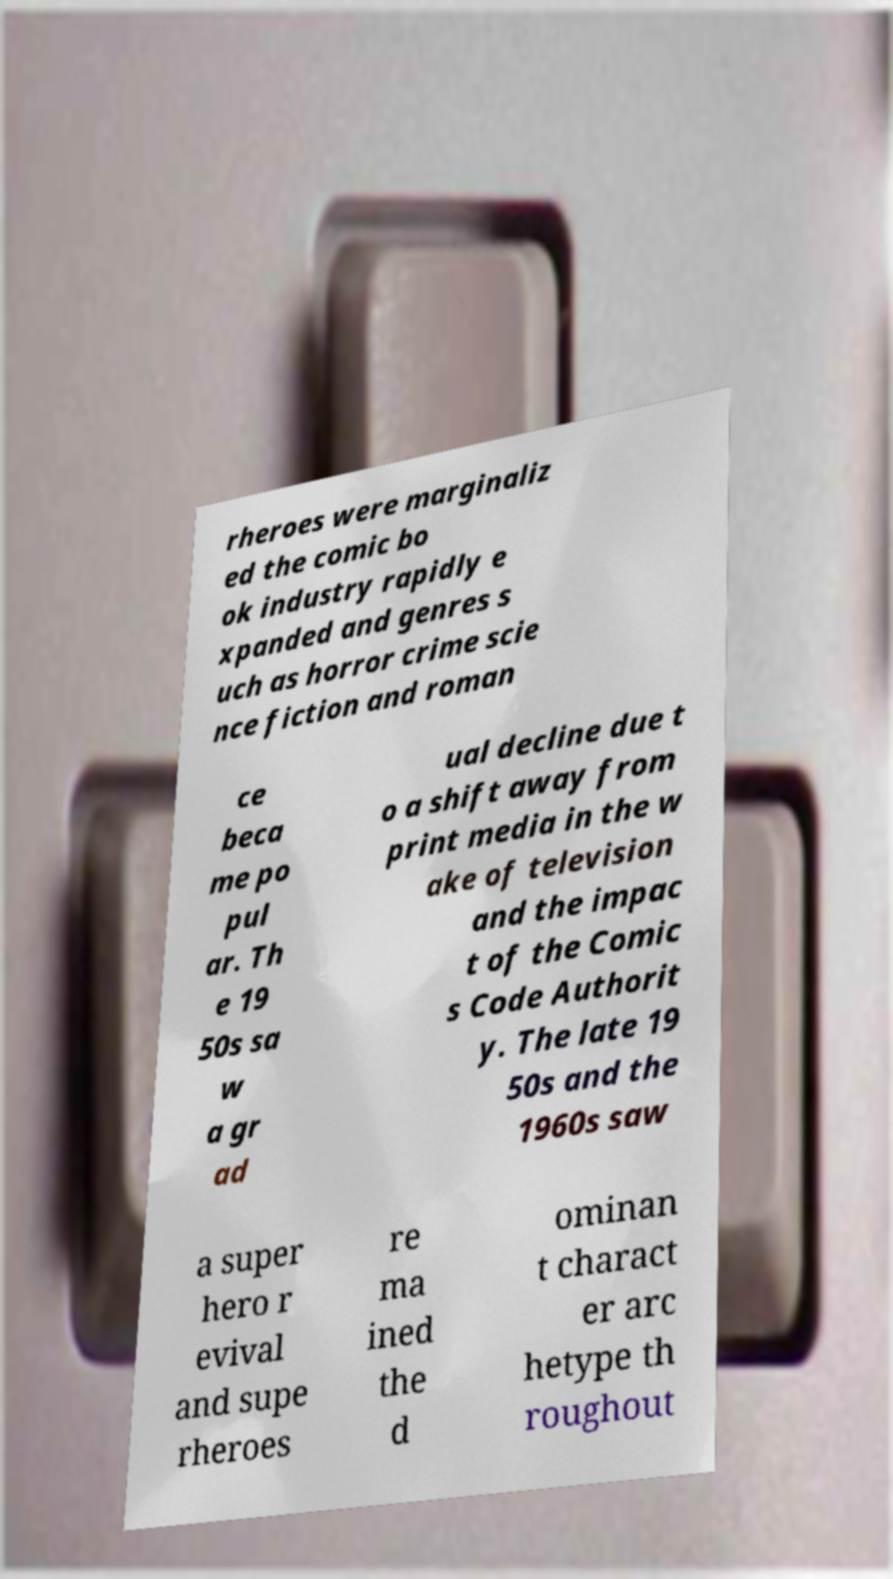Could you extract and type out the text from this image? rheroes were marginaliz ed the comic bo ok industry rapidly e xpanded and genres s uch as horror crime scie nce fiction and roman ce beca me po pul ar. Th e 19 50s sa w a gr ad ual decline due t o a shift away from print media in the w ake of television and the impac t of the Comic s Code Authorit y. The late 19 50s and the 1960s saw a super hero r evival and supe rheroes re ma ined the d ominan t charact er arc hetype th roughout 